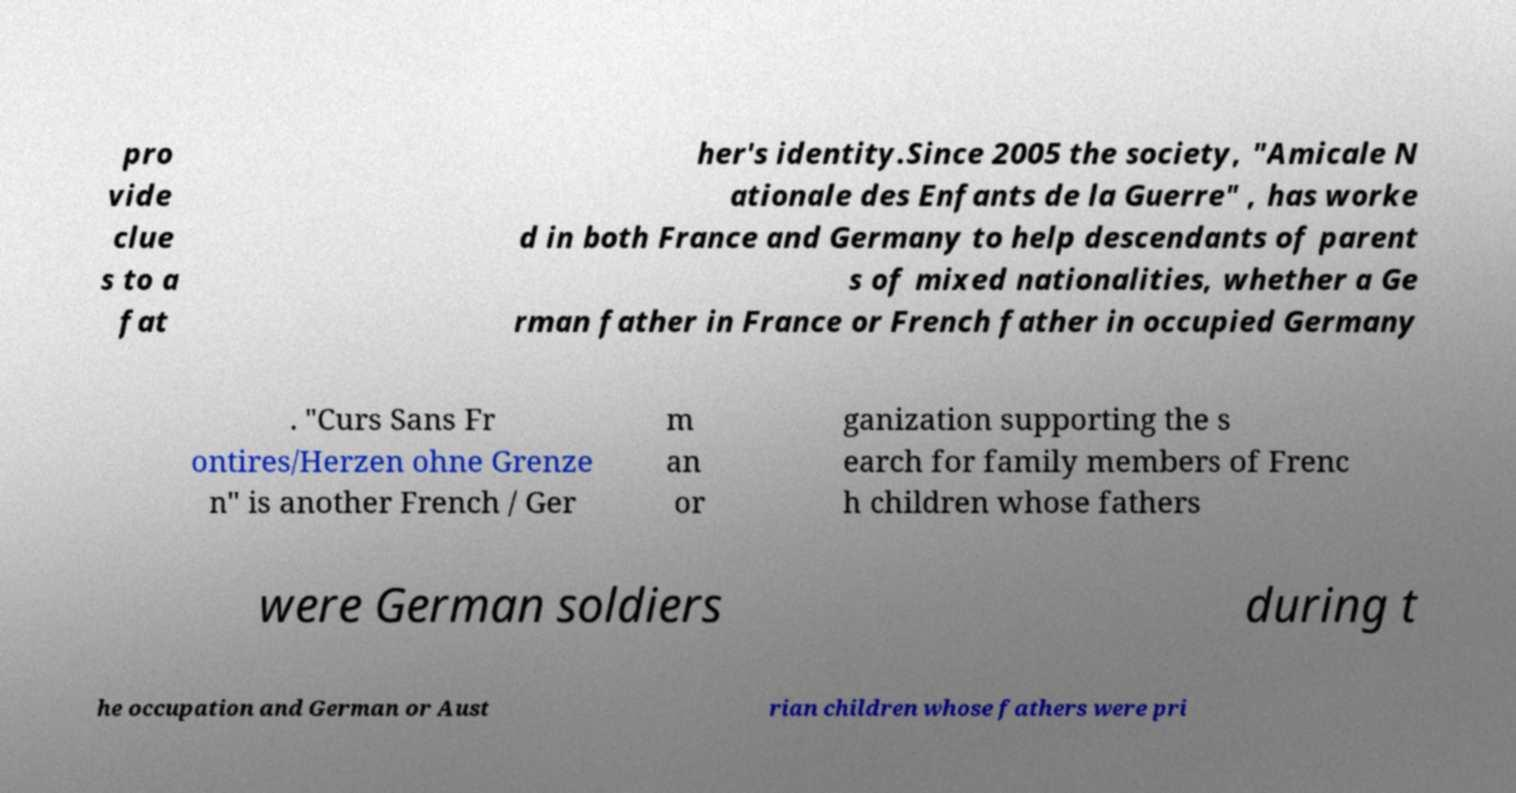What messages or text are displayed in this image? I need them in a readable, typed format. pro vide clue s to a fat her's identity.Since 2005 the society, "Amicale N ationale des Enfants de la Guerre" , has worke d in both France and Germany to help descendants of parent s of mixed nationalities, whether a Ge rman father in France or French father in occupied Germany . "Curs Sans Fr ontires/Herzen ohne Grenze n" is another French / Ger m an or ganization supporting the s earch for family members of Frenc h children whose fathers were German soldiers during t he occupation and German or Aust rian children whose fathers were pri 